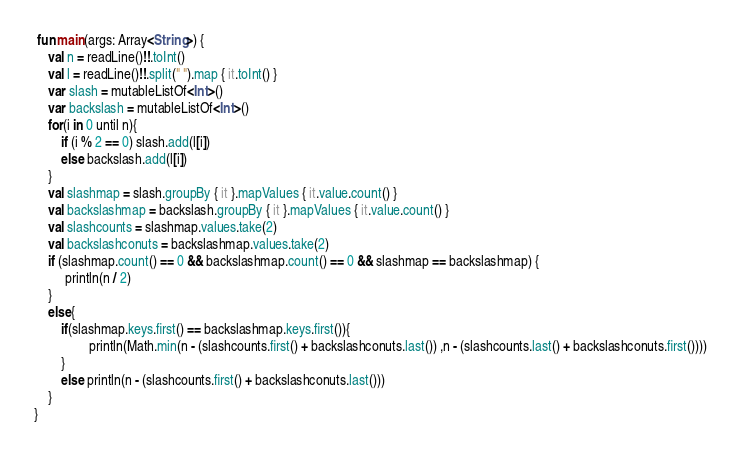<code> <loc_0><loc_0><loc_500><loc_500><_Kotlin_> fun main(args: Array<String>) {
    val n = readLine()!!.toInt()
    val l = readLine()!!.split(" ").map { it.toInt() }
    var slash = mutableListOf<Int>()
    var backslash = mutableListOf<Int>()
    for(i in 0 until n){
        if (i % 2 == 0) slash.add(l[i])
        else backslash.add(l[i])
    }
    val slashmap = slash.groupBy { it }.mapValues { it.value.count() }
    val backslashmap = backslash.groupBy { it }.mapValues { it.value.count() }
    val slashcounts = slashmap.values.take(2)
    val backslashconuts = backslashmap.values.take(2)
    if (slashmap.count() == 0 && backslashmap.count() == 0 && slashmap == backslashmap) {
         println(n / 2)
    }
    else{
        if(slashmap.keys.first() == backslashmap.keys.first()){
                println(Math.min(n - (slashcounts.first() + backslashconuts.last()) ,n - (slashcounts.last() + backslashconuts.first())))
        }
        else println(n - (slashcounts.first() + backslashconuts.last()))
    }
}</code> 